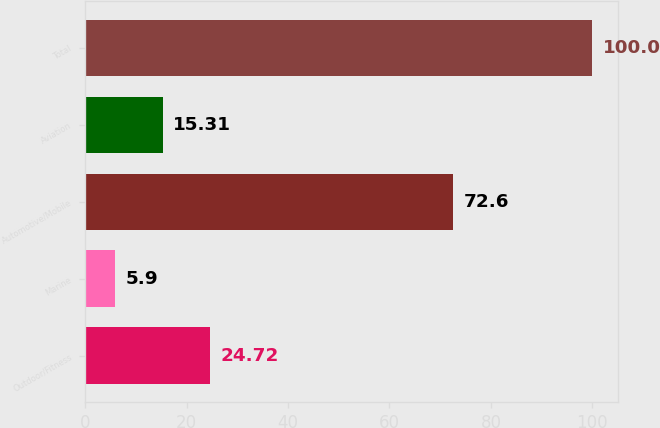Convert chart to OTSL. <chart><loc_0><loc_0><loc_500><loc_500><bar_chart><fcel>Outdoor/Fitness<fcel>Marine<fcel>Automotive/Mobile<fcel>Aviation<fcel>Total<nl><fcel>24.72<fcel>5.9<fcel>72.6<fcel>15.31<fcel>100<nl></chart> 